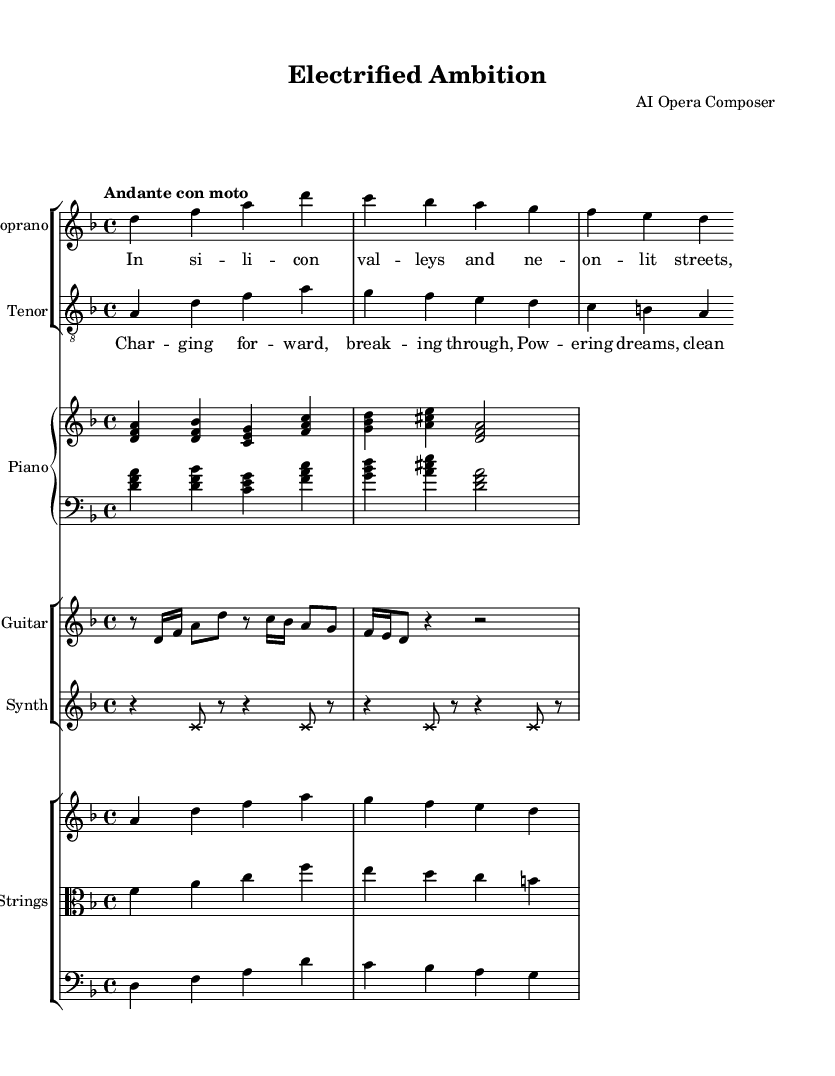What is the key signature of this music? The key signature is indicated at the beginning of the staff. Here, it shows two flats, which means the key is D minor.
Answer: D minor What is the time signature of this music? The time signature is located near the beginning of the piece, shown as 4/4. This indicates four beats per measure and a quarter note gets one beat.
Answer: 4/4 What is the tempo marking for this opera? The tempo marking is found at the beginning of the score. It states "Andante con moto," which suggests a moderately slow pace with some motion.
Answer: Andante con moto Which instrument plays the main melodic line in the first verse? The soprano voice is typically the lead in opera and carries the primary melody in the first verse as notated in the vocal line.
Answer: Soprano How many sections are there in the score? By examining the layout, there are distinct groups for vocals, piano, electric guitar, synthesizer, and strings. This breakdown shows there are five instrumental/vocal sections in total.
Answer: Five What words are sung by the tenor in the chorus? The tenor's line includes the lyrics designated in conjunction with the chorus section in the score. The provided words start with "Char -- ging for -- ward, break -- ing through" and continue on.
Answer: Charging forward, breaking through What role do the strings play in this score? The strings are grouped together and contribute both harmony and melodic support within the overall orchestration, which is typical in operatic compositions.
Answer: Harmony and support 